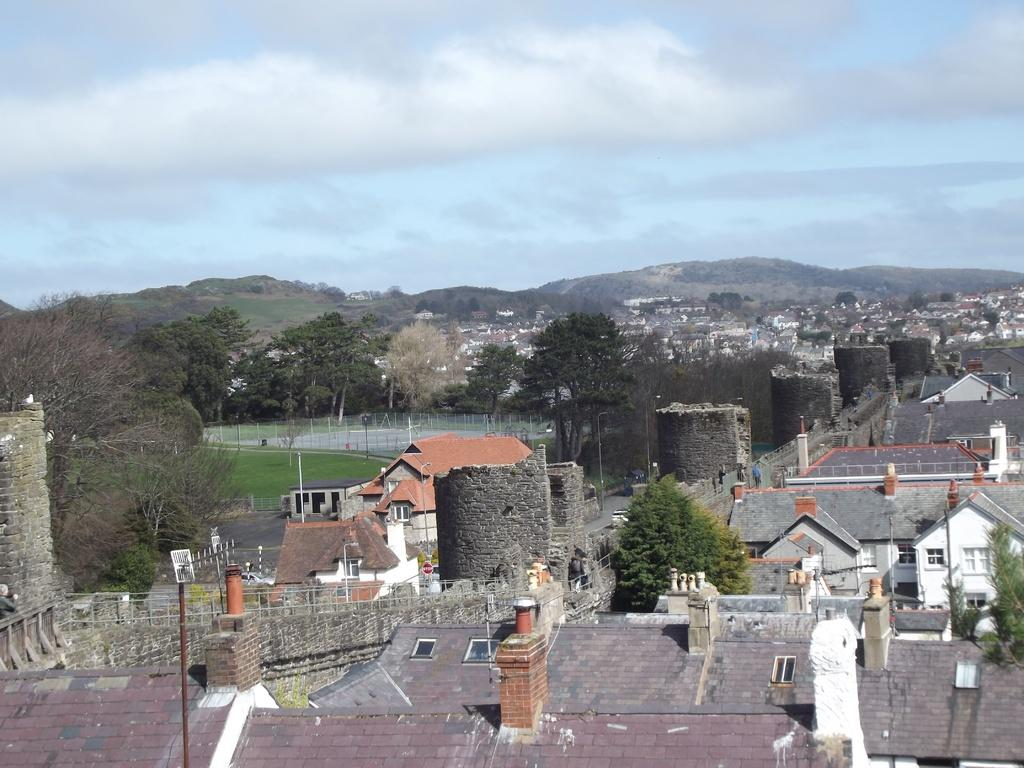What type of structures can be seen in the image? There are multiple buildings in the image. What type of vegetation is visible in the image? There is green grass and trees visible in the image. What can be seen in the background of the image? There are hills and the sky visible in the background of the image. What type of string is used to hold the note on the cork in the image? There is no note or cork present in the image, so it is not possible to determine what type of string might be used. 